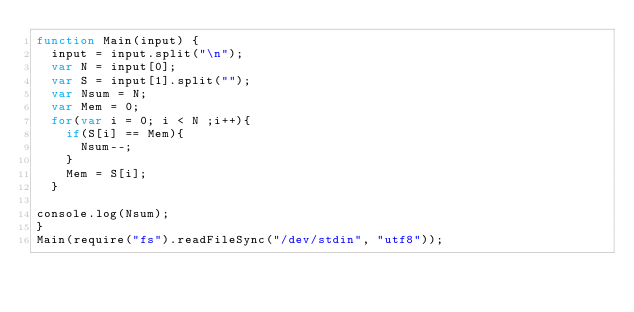<code> <loc_0><loc_0><loc_500><loc_500><_JavaScript_>function Main(input) {
  input = input.split("\n");
  var N = input[0];
  var S = input[1].split("");
  var Nsum = N;
  var Mem = 0;
  for(var i = 0; i < N ;i++){
    if(S[i] == Mem){
      Nsum--;
    }
    Mem = S[i];
  }
  
console.log(Nsum);
}
Main(require("fs").readFileSync("/dev/stdin", "utf8"));
</code> 